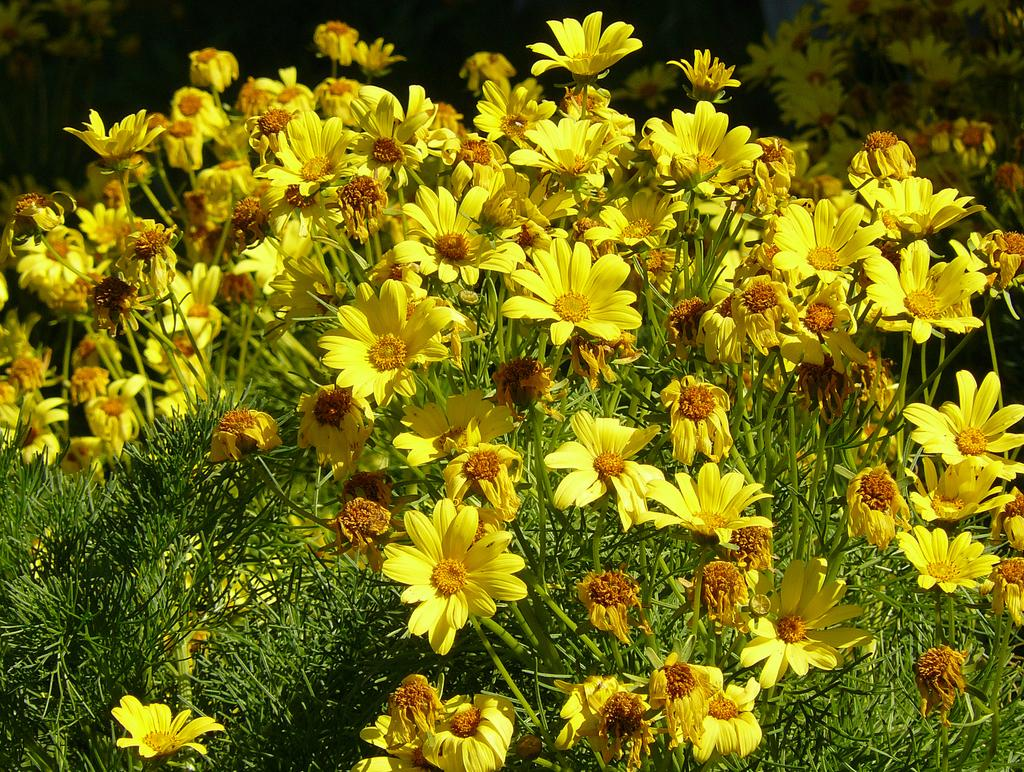What type of living organisms can be seen in the image? There are flowers and plants visible in the image. Can you describe the other items visible in the background of the image? Unfortunately, the provided facts do not give any specific details about the other items visible in the background. What type of approval is required to eat the orange in the image? There is no orange present in the image, so approval is not required for eating one. 